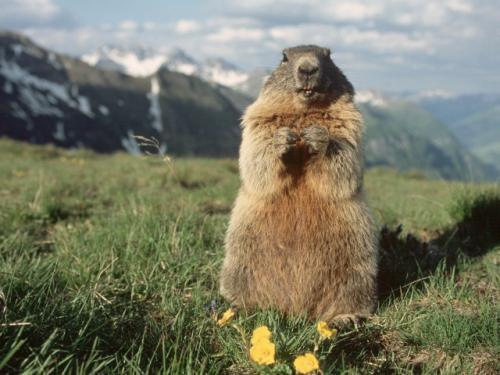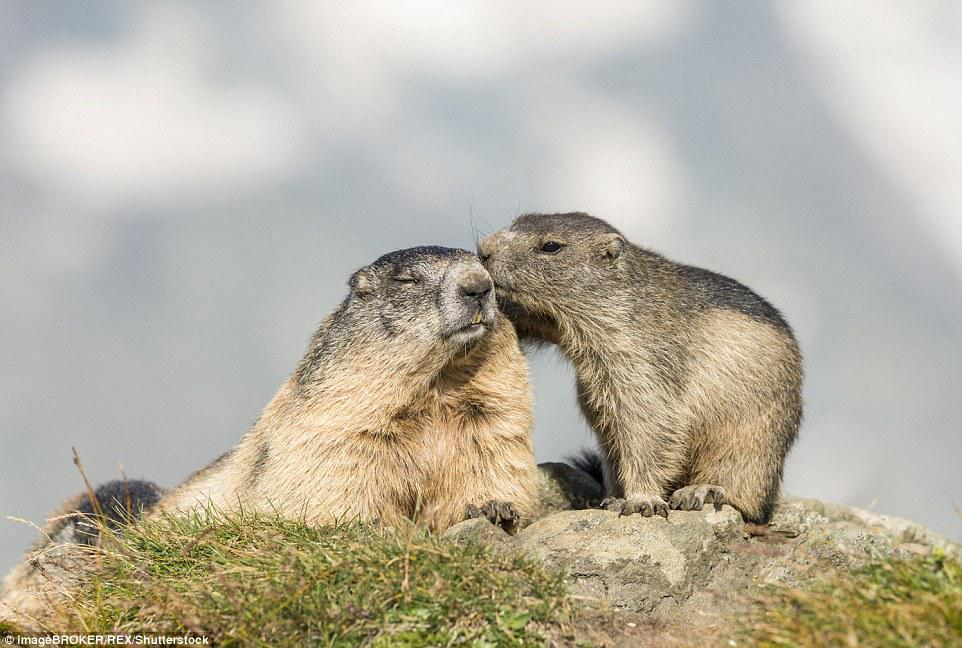The first image is the image on the left, the second image is the image on the right. Considering the images on both sides, is "Each image contains exactly one pair of marmots, and at least one pair is face-to-face." valid? Answer yes or no. No. 